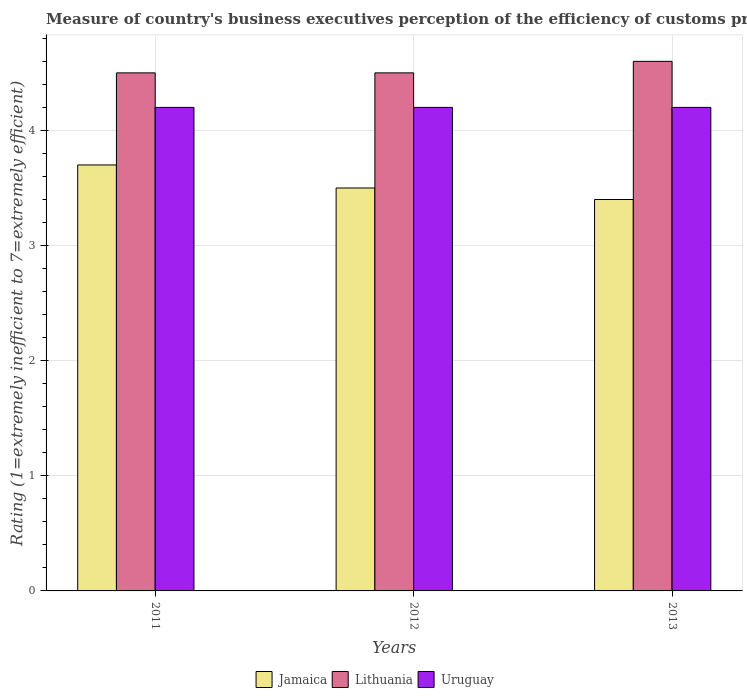Are the number of bars on each tick of the X-axis equal?
Ensure brevity in your answer.  Yes. What is the label of the 3rd group of bars from the left?
Offer a terse response. 2013. In how many cases, is the number of bars for a given year not equal to the number of legend labels?
Make the answer very short. 0. Across all years, what is the minimum rating of the efficiency of customs procedure in Uruguay?
Offer a very short reply. 4.2. In which year was the rating of the efficiency of customs procedure in Lithuania maximum?
Ensure brevity in your answer.  2013. What is the difference between the rating of the efficiency of customs procedure in Lithuania in 2011 and the rating of the efficiency of customs procedure in Jamaica in 2012?
Provide a short and direct response. 1. In the year 2013, what is the difference between the rating of the efficiency of customs procedure in Uruguay and rating of the efficiency of customs procedure in Lithuania?
Provide a succinct answer. -0.4. In how many years, is the rating of the efficiency of customs procedure in Lithuania greater than the average rating of the efficiency of customs procedure in Lithuania taken over all years?
Offer a very short reply. 1. Is the sum of the rating of the efficiency of customs procedure in Uruguay in 2011 and 2012 greater than the maximum rating of the efficiency of customs procedure in Jamaica across all years?
Your response must be concise. Yes. What does the 1st bar from the left in 2012 represents?
Your answer should be compact. Jamaica. What does the 1st bar from the right in 2012 represents?
Your answer should be very brief. Uruguay. Are the values on the major ticks of Y-axis written in scientific E-notation?
Your answer should be very brief. No. Does the graph contain any zero values?
Provide a short and direct response. No. Does the graph contain grids?
Your response must be concise. Yes. Where does the legend appear in the graph?
Keep it short and to the point. Bottom center. How many legend labels are there?
Provide a succinct answer. 3. How are the legend labels stacked?
Offer a very short reply. Horizontal. What is the title of the graph?
Keep it short and to the point. Measure of country's business executives perception of the efficiency of customs procedures. Does "Guyana" appear as one of the legend labels in the graph?
Offer a terse response. No. What is the label or title of the X-axis?
Provide a succinct answer. Years. What is the label or title of the Y-axis?
Ensure brevity in your answer.  Rating (1=extremely inefficient to 7=extremely efficient). What is the Rating (1=extremely inefficient to 7=extremely efficient) in Uruguay in 2011?
Your response must be concise. 4.2. What is the Rating (1=extremely inefficient to 7=extremely efficient) of Lithuania in 2012?
Offer a terse response. 4.5. What is the Rating (1=extremely inefficient to 7=extremely efficient) of Uruguay in 2012?
Keep it short and to the point. 4.2. What is the Rating (1=extremely inefficient to 7=extremely efficient) in Lithuania in 2013?
Offer a very short reply. 4.6. What is the Rating (1=extremely inefficient to 7=extremely efficient) of Uruguay in 2013?
Ensure brevity in your answer.  4.2. Across all years, what is the maximum Rating (1=extremely inefficient to 7=extremely efficient) in Uruguay?
Give a very brief answer. 4.2. Across all years, what is the minimum Rating (1=extremely inefficient to 7=extremely efficient) in Jamaica?
Provide a succinct answer. 3.4. Across all years, what is the minimum Rating (1=extremely inefficient to 7=extremely efficient) in Lithuania?
Offer a very short reply. 4.5. What is the total Rating (1=extremely inefficient to 7=extremely efficient) in Jamaica in the graph?
Your answer should be compact. 10.6. What is the total Rating (1=extremely inefficient to 7=extremely efficient) in Lithuania in the graph?
Your answer should be compact. 13.6. What is the difference between the Rating (1=extremely inefficient to 7=extremely efficient) of Uruguay in 2011 and that in 2012?
Your answer should be compact. 0. What is the difference between the Rating (1=extremely inefficient to 7=extremely efficient) in Jamaica in 2011 and that in 2013?
Ensure brevity in your answer.  0.3. What is the difference between the Rating (1=extremely inefficient to 7=extremely efficient) in Lithuania in 2011 and that in 2013?
Ensure brevity in your answer.  -0.1. What is the difference between the Rating (1=extremely inefficient to 7=extremely efficient) of Lithuania in 2012 and that in 2013?
Provide a succinct answer. -0.1. What is the difference between the Rating (1=extremely inefficient to 7=extremely efficient) in Uruguay in 2012 and that in 2013?
Offer a very short reply. 0. What is the difference between the Rating (1=extremely inefficient to 7=extremely efficient) of Lithuania in 2011 and the Rating (1=extremely inefficient to 7=extremely efficient) of Uruguay in 2013?
Give a very brief answer. 0.3. What is the average Rating (1=extremely inefficient to 7=extremely efficient) in Jamaica per year?
Your response must be concise. 3.53. What is the average Rating (1=extremely inefficient to 7=extremely efficient) of Lithuania per year?
Offer a very short reply. 4.53. In the year 2011, what is the difference between the Rating (1=extremely inefficient to 7=extremely efficient) of Jamaica and Rating (1=extremely inefficient to 7=extremely efficient) of Lithuania?
Give a very brief answer. -0.8. In the year 2012, what is the difference between the Rating (1=extremely inefficient to 7=extremely efficient) of Jamaica and Rating (1=extremely inefficient to 7=extremely efficient) of Uruguay?
Offer a terse response. -0.7. In the year 2013, what is the difference between the Rating (1=extremely inefficient to 7=extremely efficient) of Jamaica and Rating (1=extremely inefficient to 7=extremely efficient) of Lithuania?
Give a very brief answer. -1.2. In the year 2013, what is the difference between the Rating (1=extremely inefficient to 7=extremely efficient) of Jamaica and Rating (1=extremely inefficient to 7=extremely efficient) of Uruguay?
Give a very brief answer. -0.8. In the year 2013, what is the difference between the Rating (1=extremely inefficient to 7=extremely efficient) in Lithuania and Rating (1=extremely inefficient to 7=extremely efficient) in Uruguay?
Keep it short and to the point. 0.4. What is the ratio of the Rating (1=extremely inefficient to 7=extremely efficient) in Jamaica in 2011 to that in 2012?
Provide a succinct answer. 1.06. What is the ratio of the Rating (1=extremely inefficient to 7=extremely efficient) of Lithuania in 2011 to that in 2012?
Ensure brevity in your answer.  1. What is the ratio of the Rating (1=extremely inefficient to 7=extremely efficient) in Jamaica in 2011 to that in 2013?
Provide a short and direct response. 1.09. What is the ratio of the Rating (1=extremely inefficient to 7=extremely efficient) in Lithuania in 2011 to that in 2013?
Offer a terse response. 0.98. What is the ratio of the Rating (1=extremely inefficient to 7=extremely efficient) of Uruguay in 2011 to that in 2013?
Keep it short and to the point. 1. What is the ratio of the Rating (1=extremely inefficient to 7=extremely efficient) in Jamaica in 2012 to that in 2013?
Offer a terse response. 1.03. What is the ratio of the Rating (1=extremely inefficient to 7=extremely efficient) of Lithuania in 2012 to that in 2013?
Your response must be concise. 0.98. What is the ratio of the Rating (1=extremely inefficient to 7=extremely efficient) of Uruguay in 2012 to that in 2013?
Provide a short and direct response. 1. What is the difference between the highest and the second highest Rating (1=extremely inefficient to 7=extremely efficient) of Lithuania?
Offer a very short reply. 0.1. What is the difference between the highest and the lowest Rating (1=extremely inefficient to 7=extremely efficient) in Lithuania?
Offer a very short reply. 0.1. What is the difference between the highest and the lowest Rating (1=extremely inefficient to 7=extremely efficient) of Uruguay?
Give a very brief answer. 0. 